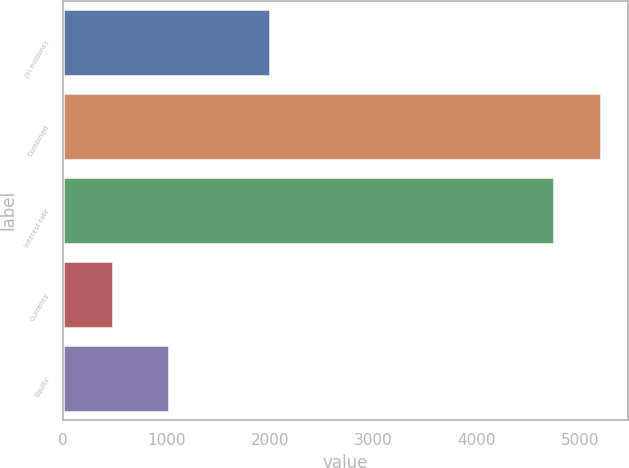Convert chart to OTSL. <chart><loc_0><loc_0><loc_500><loc_500><bar_chart><fcel>(in millions)<fcel>Combined<fcel>Interest rate<fcel>Currency<fcel>Equity<nl><fcel>2004<fcel>5204.6<fcel>4750<fcel>478<fcel>1024<nl></chart> 